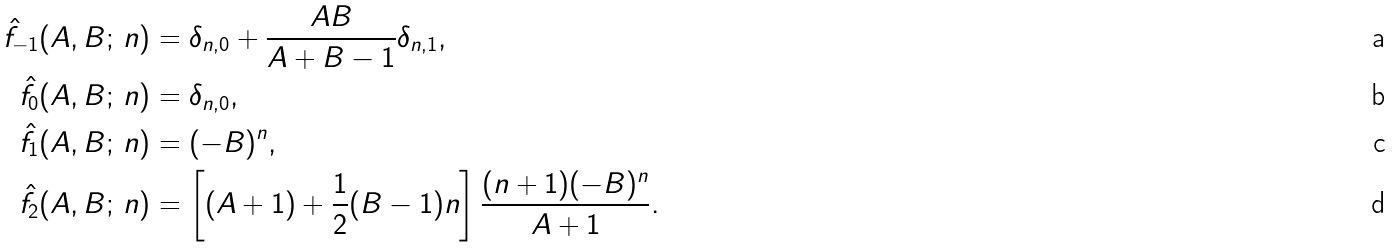Convert formula to latex. <formula><loc_0><loc_0><loc_500><loc_500>\hat { f } _ { - 1 } ( A , B ; \, n ) & = \delta _ { n , 0 } + \frac { A B } { A + B - 1 } \delta _ { n , 1 } , \\ \hat { f } _ { 0 } ( A , B ; \, n ) & = \delta _ { n , 0 } , \\ \hat { f } _ { 1 } ( A , B ; \, n ) & = ( - B ) ^ { n } , \\ \hat { f } _ { 2 } ( A , B ; \, n ) & = \left [ ( A + 1 ) + \frac { 1 } { 2 } ( B - 1 ) n \right ] \frac { ( n + 1 ) ( - B ) ^ { n } } { A + 1 } .</formula> 